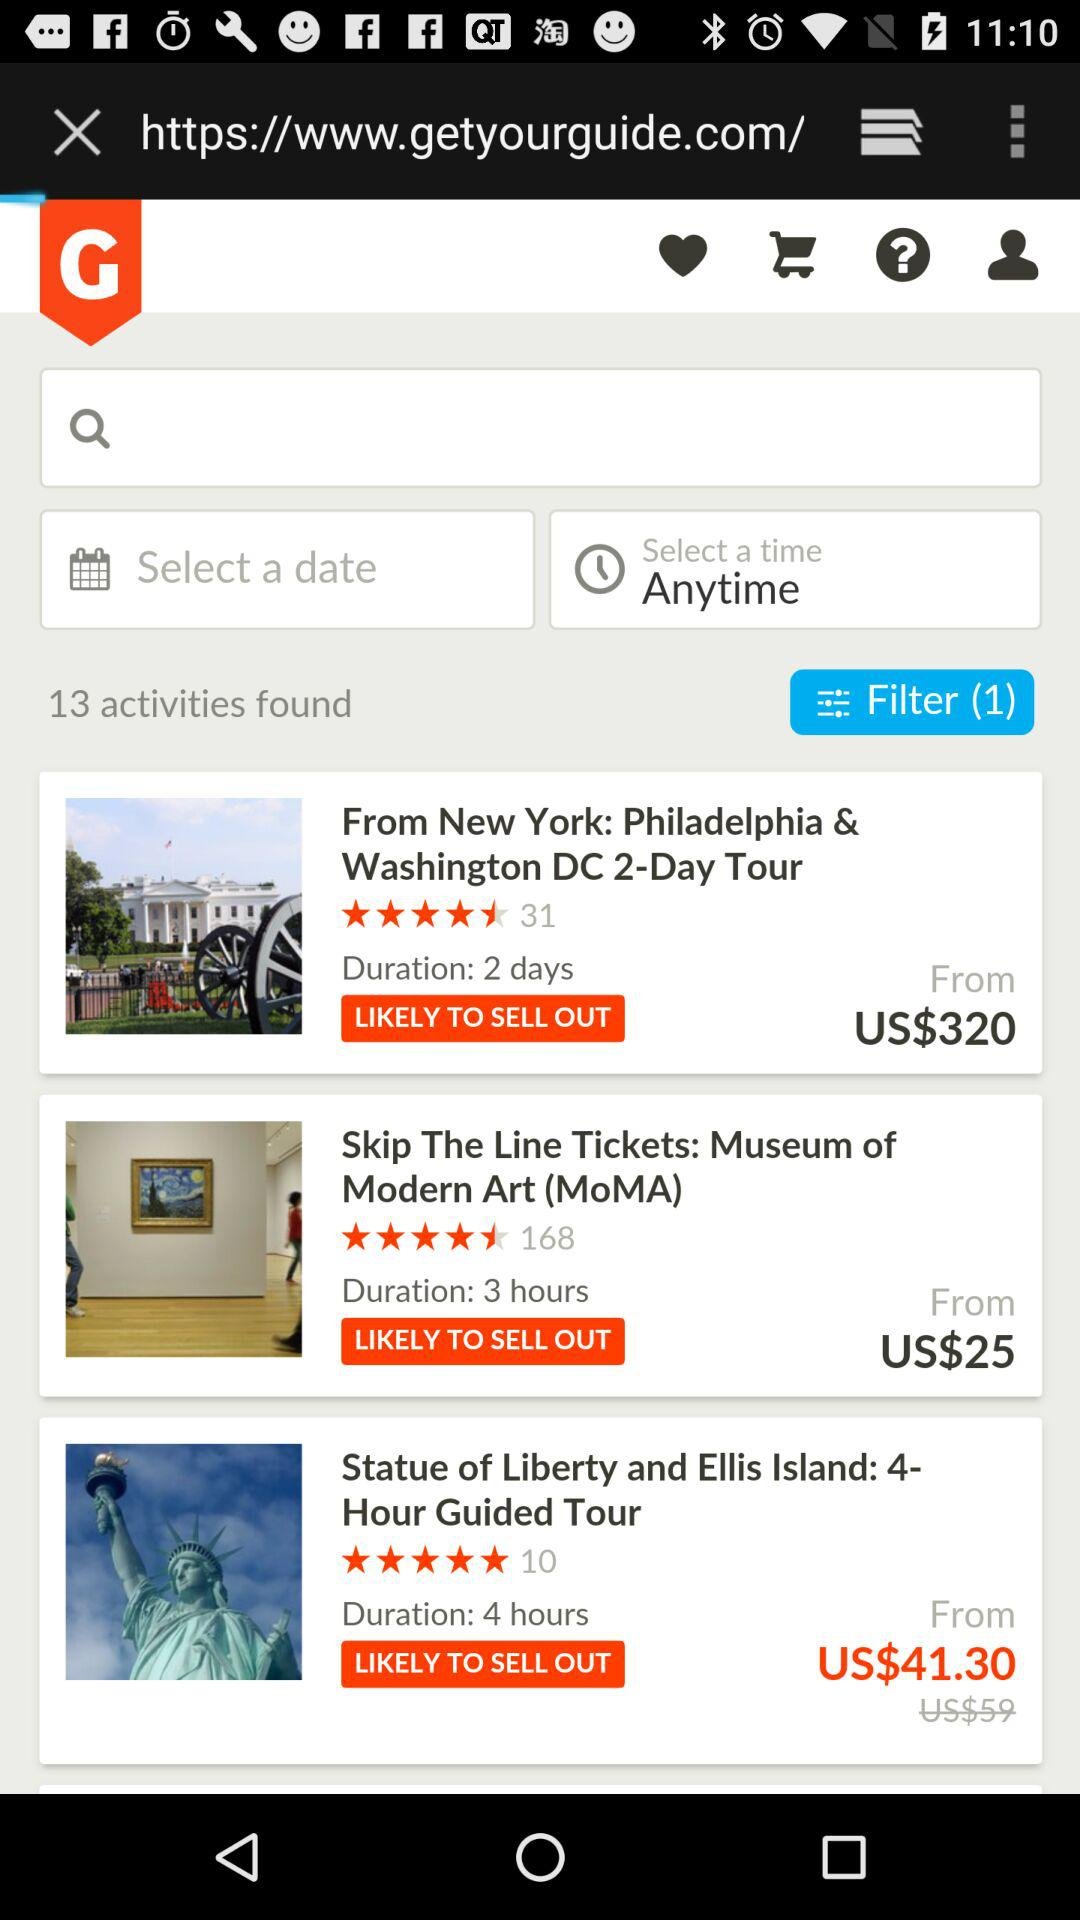What is the rating for the Museum of Modern Art? The rating is 4.5 stars. 